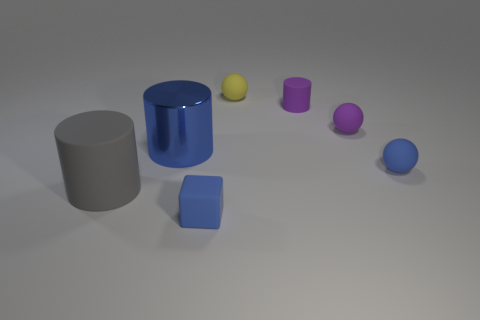The small sphere behind the small purple matte object to the right of the purple rubber cylinder is what color? The small sphere situated behind the purple matte object, which is to the right of the glossy purple cylinder, exhibits a yellow hue. 